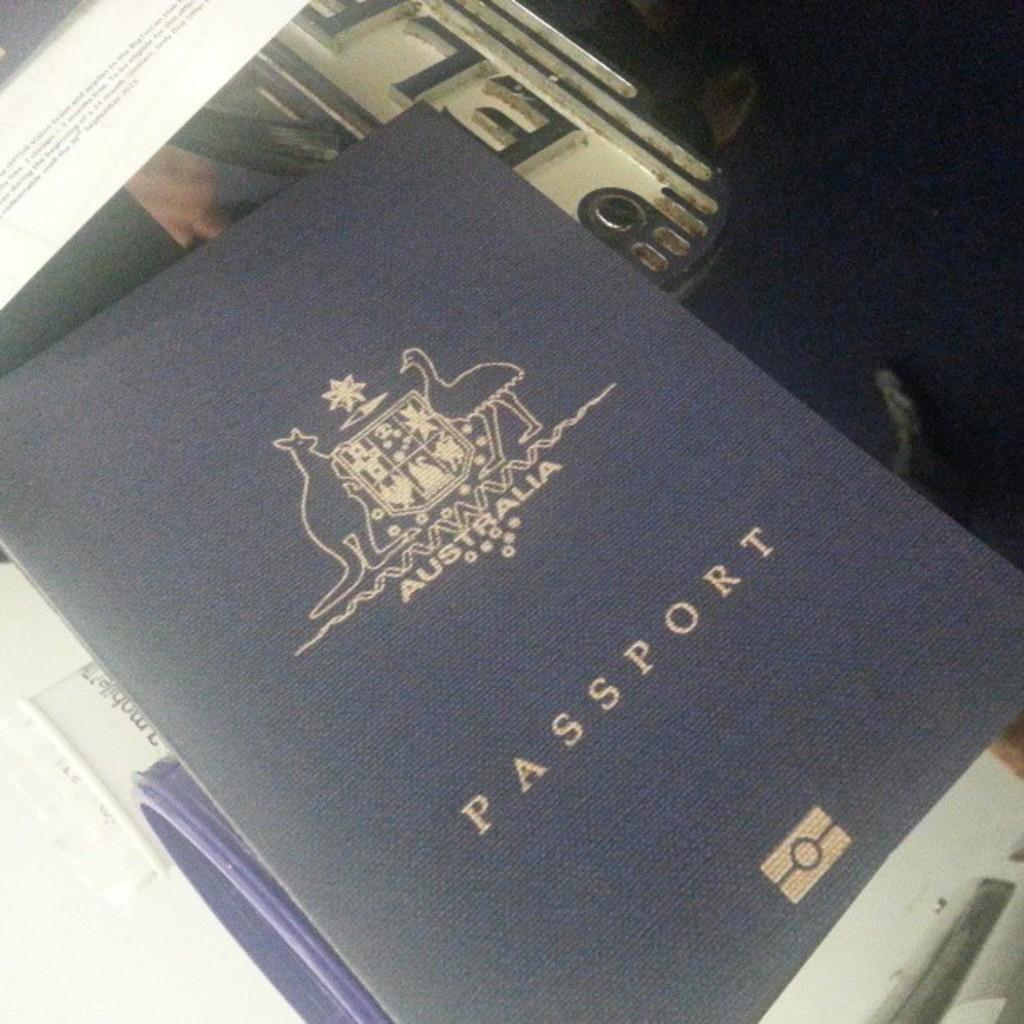<image>
Share a concise interpretation of the image provided. A navy blue passport booklet is shown here. 